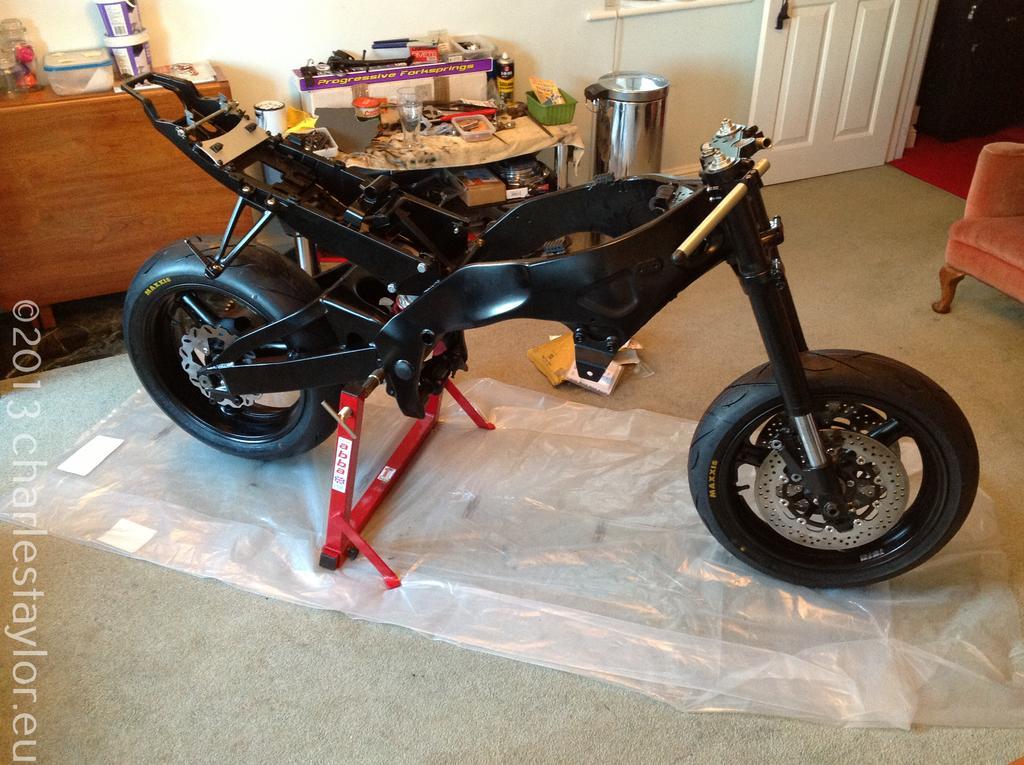Please provide a concise description of this image. In this picture we can see a motorcycle frame which consists of two wheels, in the bottom there is a cover, in the background we can see a dustbin, on the right side of the picture we can see a cher, here we can see one door, on the left side of this picture we can see a cupboard. 